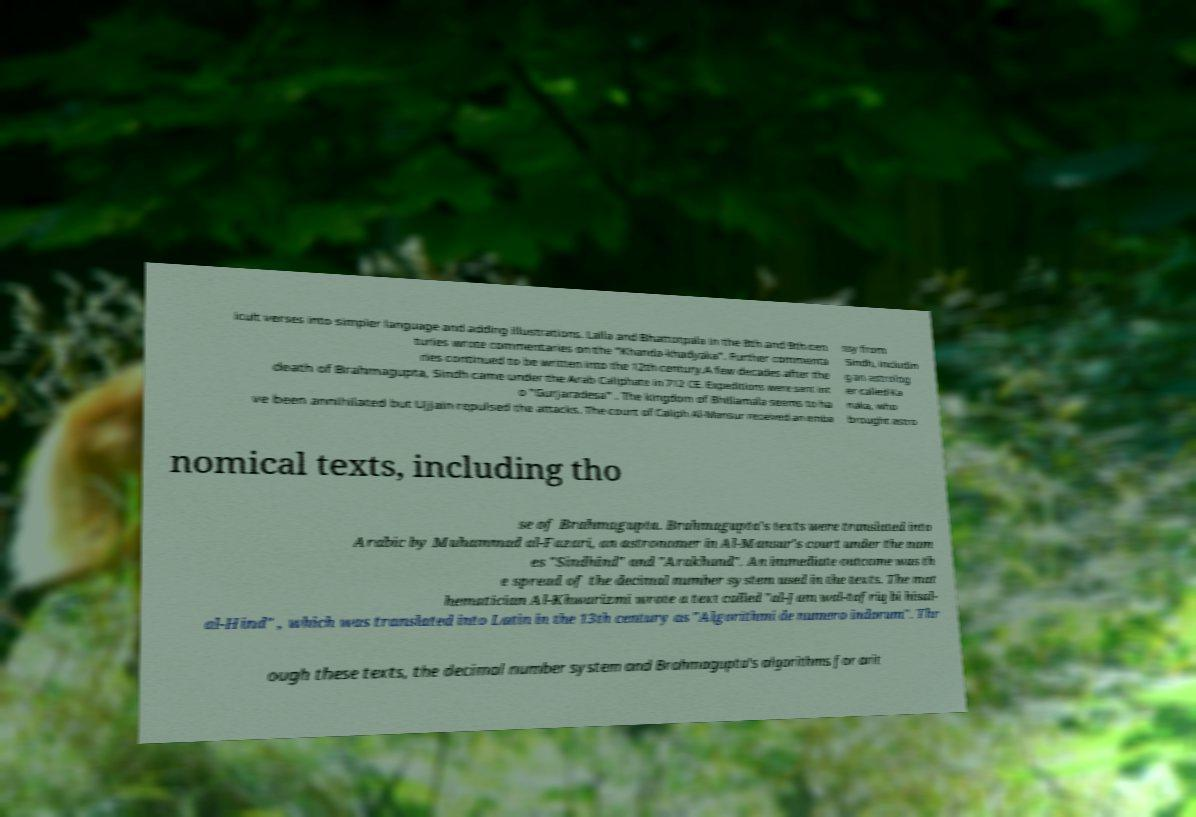Please read and relay the text visible in this image. What does it say? icult verses into simpler language and adding illustrations. Lalla and Bhattotpala in the 8th and 9th cen turies wrote commentaries on the "Khanda-khadyaka". Further commenta ries continued to be written into the 12th century.A few decades after the death of Brahmagupta, Sindh came under the Arab Caliphate in 712 CE. Expeditions were sent int o "Gurjaradesa" . The kingdom of Bhillamala seems to ha ve been annihilated but Ujjain repulsed the attacks. The court of Caliph Al-Mansur received an emba ssy from Sindh, includin g an astrolog er called Ka naka, who brought astro nomical texts, including tho se of Brahmagupta. Brahmagupta's texts were translated into Arabic by Muhammad al-Fazari, an astronomer in Al-Mansur's court under the nam es "Sindhind" and "Arakhand". An immediate outcome was th e spread of the decimal number system used in the texts. The mat hematician Al-Khwarizmi wrote a text called "al-Jam wal-tafriq bi hisal- al-Hind" , which was translated into Latin in the 13th century as "Algorithmi de numero indorum". Thr ough these texts, the decimal number system and Brahmagupta's algorithms for arit 